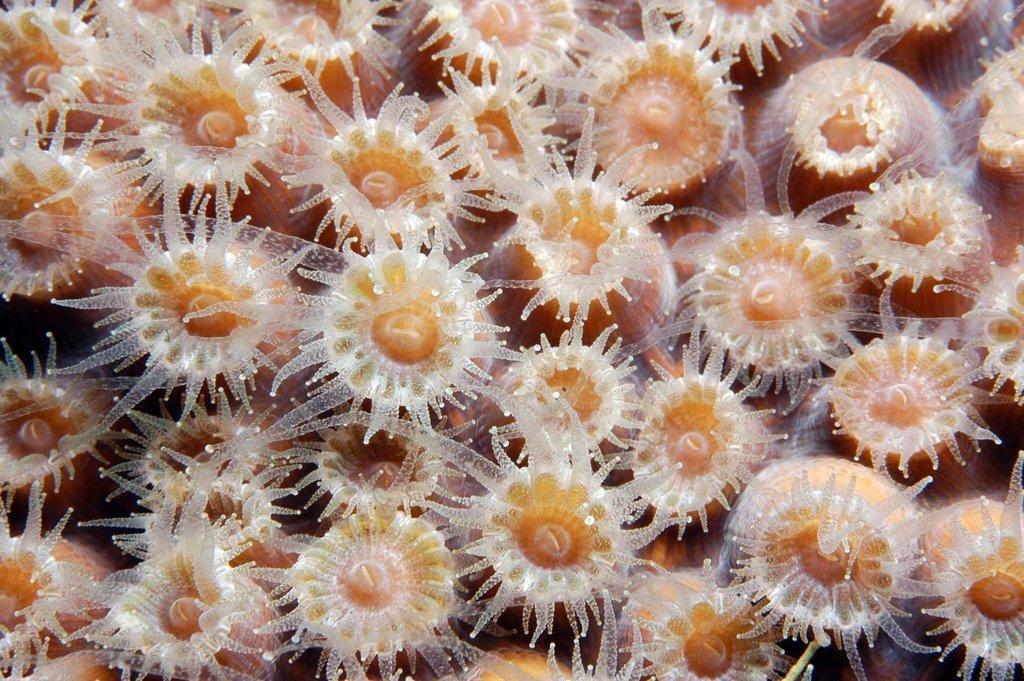In one or two sentences, can you explain what this image depicts? In the image there are white and orange color polyps of coral reefs. 